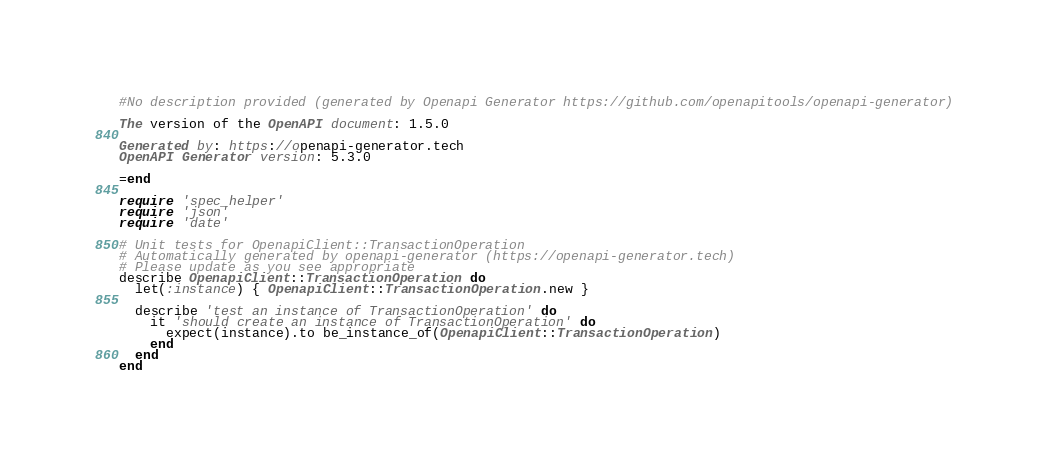<code> <loc_0><loc_0><loc_500><loc_500><_Ruby_>
#No description provided (generated by Openapi Generator https://github.com/openapitools/openapi-generator)

The version of the OpenAPI document: 1.5.0

Generated by: https://openapi-generator.tech
OpenAPI Generator version: 5.3.0

=end

require 'spec_helper'
require 'json'
require 'date'

# Unit tests for OpenapiClient::TransactionOperation
# Automatically generated by openapi-generator (https://openapi-generator.tech)
# Please update as you see appropriate
describe OpenapiClient::TransactionOperation do
  let(:instance) { OpenapiClient::TransactionOperation.new }

  describe 'test an instance of TransactionOperation' do
    it 'should create an instance of TransactionOperation' do
      expect(instance).to be_instance_of(OpenapiClient::TransactionOperation)
    end
  end
end
</code> 